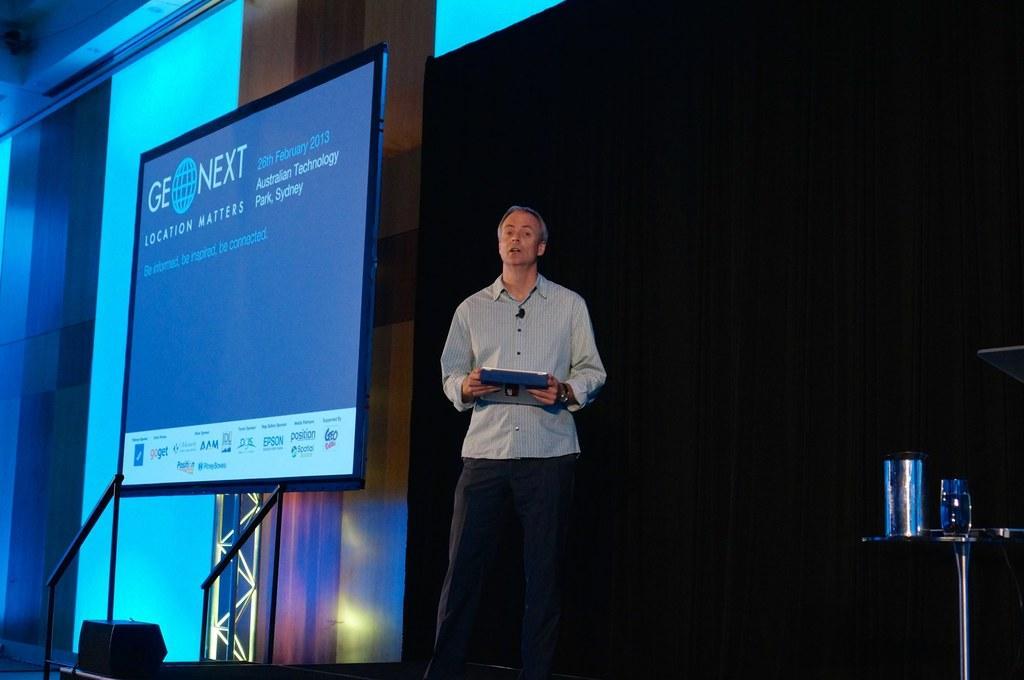Could you give a brief overview of what you see in this image? In this image we can see a man standing on the dais and holding a book in the hands. In the background there are railings, electric lights, display screen and a side table on which containers are placed. 